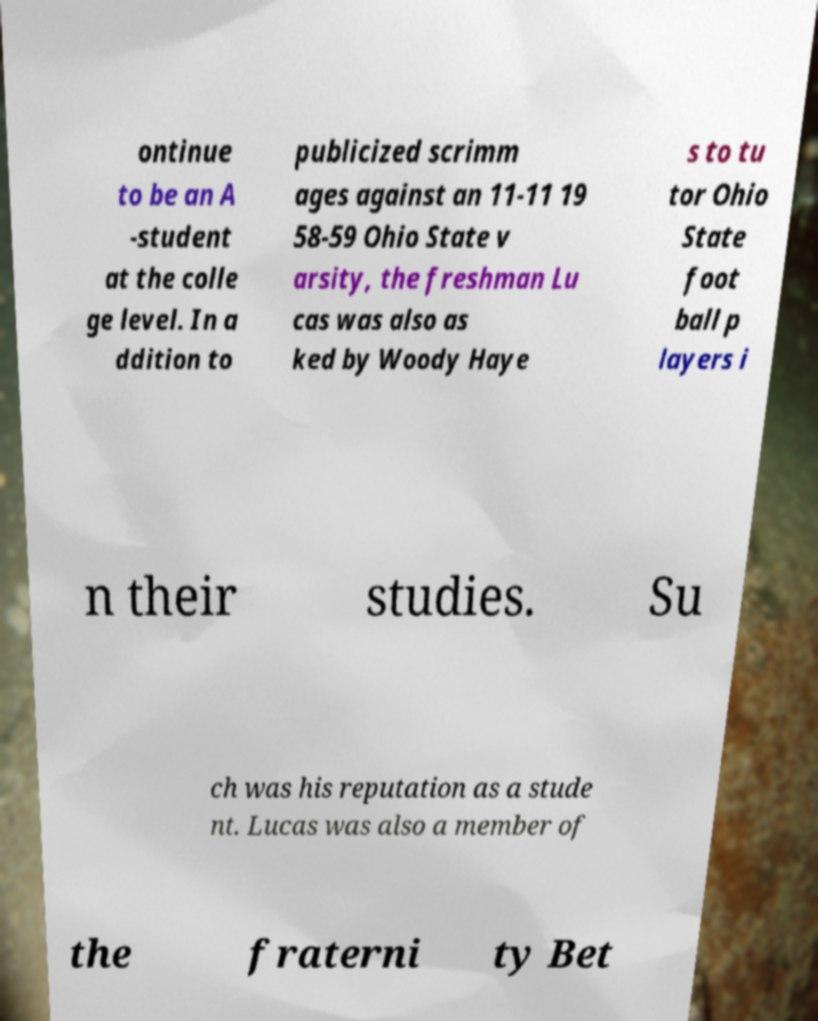There's text embedded in this image that I need extracted. Can you transcribe it verbatim? ontinue to be an A -student at the colle ge level. In a ddition to publicized scrimm ages against an 11-11 19 58-59 Ohio State v arsity, the freshman Lu cas was also as ked by Woody Haye s to tu tor Ohio State foot ball p layers i n their studies. Su ch was his reputation as a stude nt. Lucas was also a member of the fraterni ty Bet 